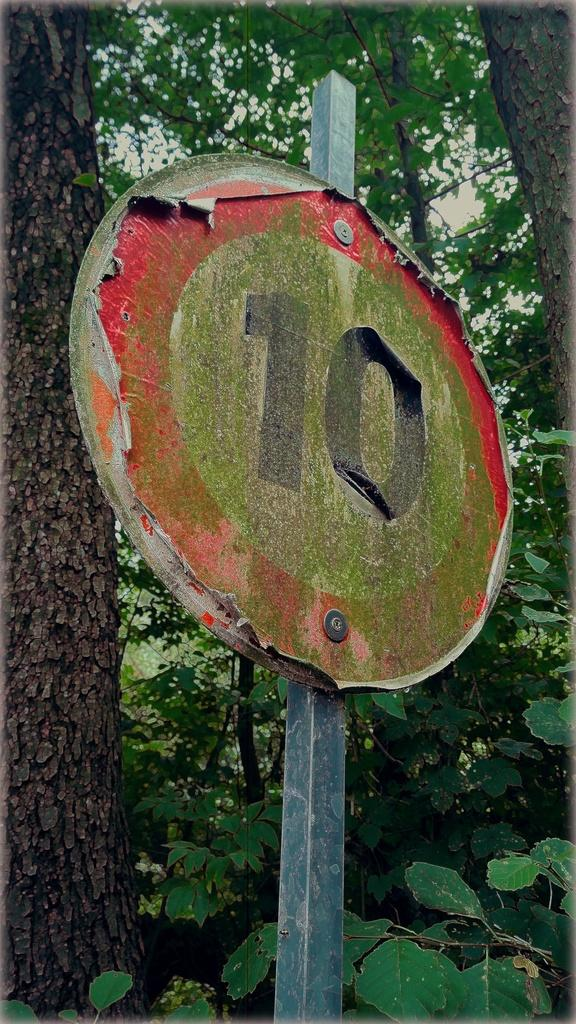What is the main object in the image? There is a pole in the image. What is attached to the pole? There is a sign board on the pole. What can be seen in the background of the image? Trees are visible behind the pole. How many slices of pie are on the pole in the image? There is no pie present in the image; it features a pole with a sign board. What type of observation can be made about the visitors in the image? There is no mention of visitors in the image, as it only shows a pole with a sign board and trees in the background. 